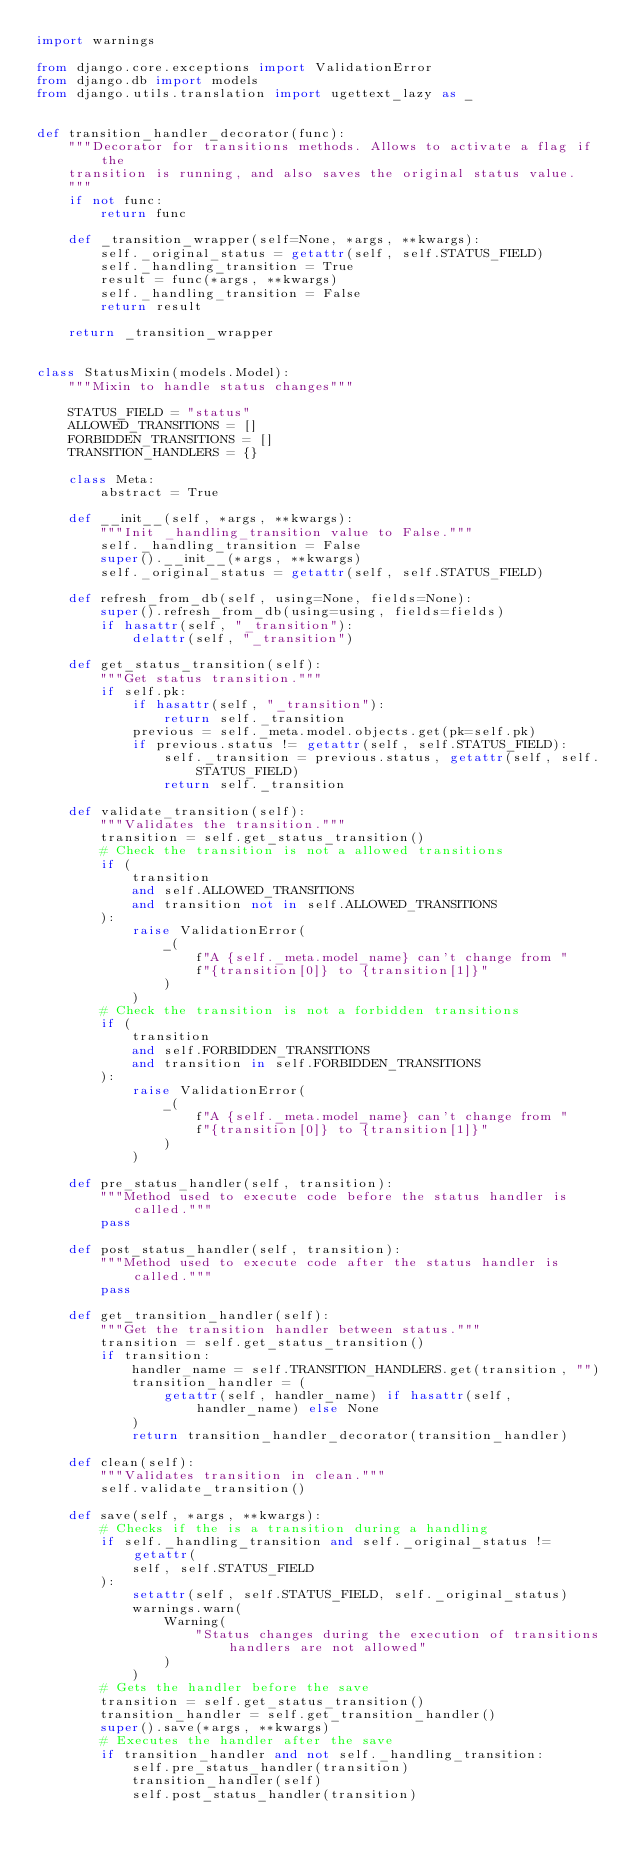Convert code to text. <code><loc_0><loc_0><loc_500><loc_500><_Python_>import warnings

from django.core.exceptions import ValidationError
from django.db import models
from django.utils.translation import ugettext_lazy as _


def transition_handler_decorator(func):
    """Decorator for transitions methods. Allows to activate a flag if the
    transition is running, and also saves the original status value.
    """
    if not func:
        return func

    def _transition_wrapper(self=None, *args, **kwargs):
        self._original_status = getattr(self, self.STATUS_FIELD)
        self._handling_transition = True
        result = func(*args, **kwargs)
        self._handling_transition = False
        return result

    return _transition_wrapper


class StatusMixin(models.Model):
    """Mixin to handle status changes"""

    STATUS_FIELD = "status"
    ALLOWED_TRANSITIONS = []
    FORBIDDEN_TRANSITIONS = []
    TRANSITION_HANDLERS = {}

    class Meta:
        abstract = True

    def __init__(self, *args, **kwargs):
        """Init _handling_transition value to False."""
        self._handling_transition = False
        super().__init__(*args, **kwargs)
        self._original_status = getattr(self, self.STATUS_FIELD)

    def refresh_from_db(self, using=None, fields=None):
        super().refresh_from_db(using=using, fields=fields)
        if hasattr(self, "_transition"):
            delattr(self, "_transition")

    def get_status_transition(self):
        """Get status transition."""
        if self.pk:
            if hasattr(self, "_transition"):
                return self._transition
            previous = self._meta.model.objects.get(pk=self.pk)
            if previous.status != getattr(self, self.STATUS_FIELD):
                self._transition = previous.status, getattr(self, self.STATUS_FIELD)
                return self._transition

    def validate_transition(self):
        """Validates the transition."""
        transition = self.get_status_transition()
        # Check the transition is not a allowed transitions
        if (
            transition
            and self.ALLOWED_TRANSITIONS
            and transition not in self.ALLOWED_TRANSITIONS
        ):
            raise ValidationError(
                _(
                    f"A {self._meta.model_name} can't change from "
                    f"{transition[0]} to {transition[1]}"
                )
            )
        # Check the transition is not a forbidden transitions
        if (
            transition
            and self.FORBIDDEN_TRANSITIONS
            and transition in self.FORBIDDEN_TRANSITIONS
        ):
            raise ValidationError(
                _(
                    f"A {self._meta.model_name} can't change from "
                    f"{transition[0]} to {transition[1]}"
                )
            )

    def pre_status_handler(self, transition):
        """Method used to execute code before the status handler is called."""
        pass

    def post_status_handler(self, transition):
        """Method used to execute code after the status handler is called."""
        pass

    def get_transition_handler(self):
        """Get the transition handler between status."""
        transition = self.get_status_transition()
        if transition:
            handler_name = self.TRANSITION_HANDLERS.get(transition, "")
            transition_handler = (
                getattr(self, handler_name) if hasattr(self, handler_name) else None
            )
            return transition_handler_decorator(transition_handler)

    def clean(self):
        """Validates transition in clean."""
        self.validate_transition()

    def save(self, *args, **kwargs):
        # Checks if the is a transition during a handling
        if self._handling_transition and self._original_status != getattr(
            self, self.STATUS_FIELD
        ):
            setattr(self, self.STATUS_FIELD, self._original_status)
            warnings.warn(
                Warning(
                    "Status changes during the execution of transitions handlers are not allowed"
                )
            )
        # Gets the handler before the save
        transition = self.get_status_transition()
        transition_handler = self.get_transition_handler()
        super().save(*args, **kwargs)
        # Executes the handler after the save
        if transition_handler and not self._handling_transition:
            self.pre_status_handler(transition)
            transition_handler(self)
            self.post_status_handler(transition)
</code> 